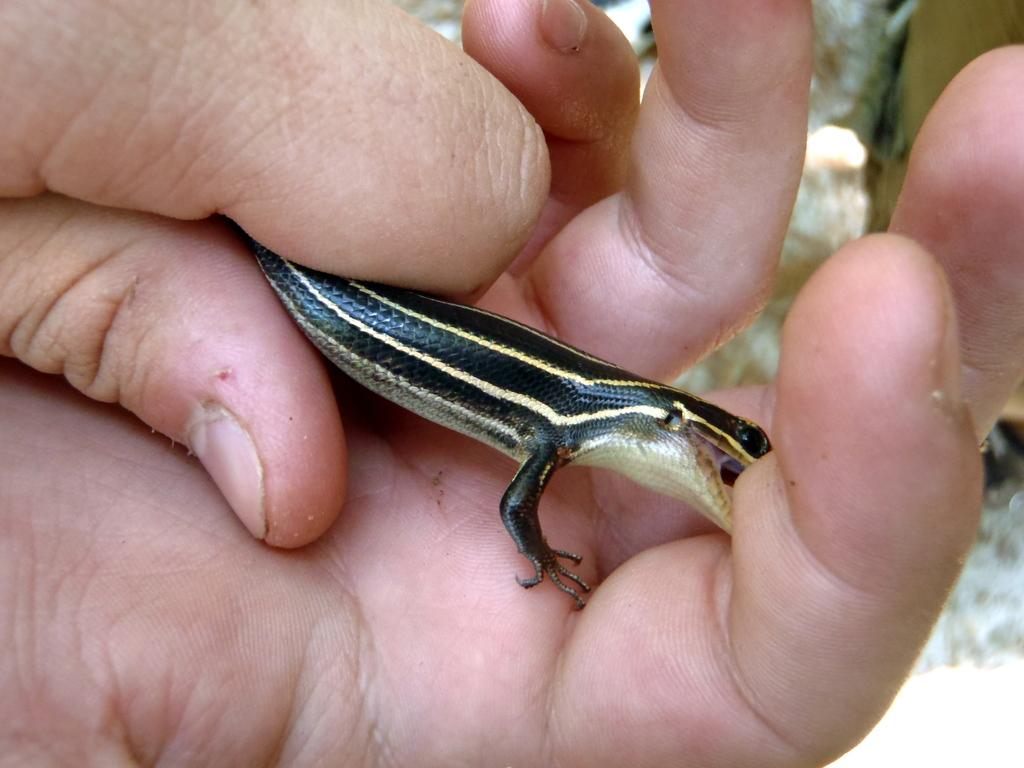What type of animal is in the image? There is a reptile in the image. How is the reptile being held in the image? The reptile is being held by someone. What type of pets are visible in the image? There is no mention of pets in the image; it only features a reptile being held by someone. Is the manager holding the reptile in the image? There is no mention of a manager in the image, only someone holding the reptile. 